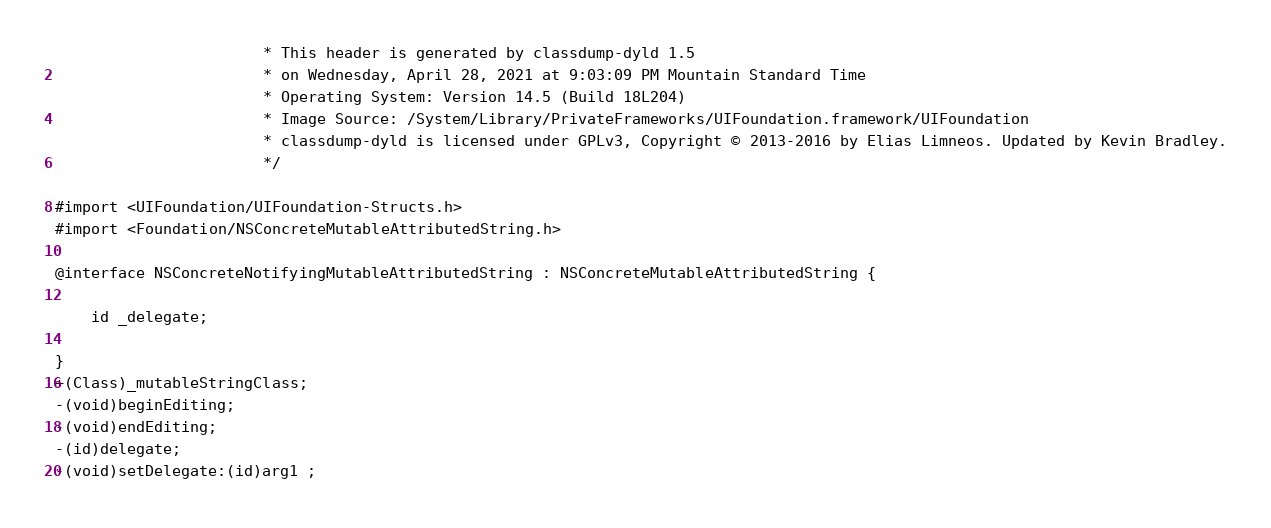Convert code to text. <code><loc_0><loc_0><loc_500><loc_500><_C_>                       * This header is generated by classdump-dyld 1.5
                       * on Wednesday, April 28, 2021 at 9:03:09 PM Mountain Standard Time
                       * Operating System: Version 14.5 (Build 18L204)
                       * Image Source: /System/Library/PrivateFrameworks/UIFoundation.framework/UIFoundation
                       * classdump-dyld is licensed under GPLv3, Copyright © 2013-2016 by Elias Limneos. Updated by Kevin Bradley.
                       */

#import <UIFoundation/UIFoundation-Structs.h>
#import <Foundation/NSConcreteMutableAttributedString.h>

@interface NSConcreteNotifyingMutableAttributedString : NSConcreteMutableAttributedString {

	id _delegate;

}
+(Class)_mutableStringClass;
-(void)beginEditing;
-(void)endEditing;
-(id)delegate;
-(void)setDelegate:(id)arg1 ;</code> 